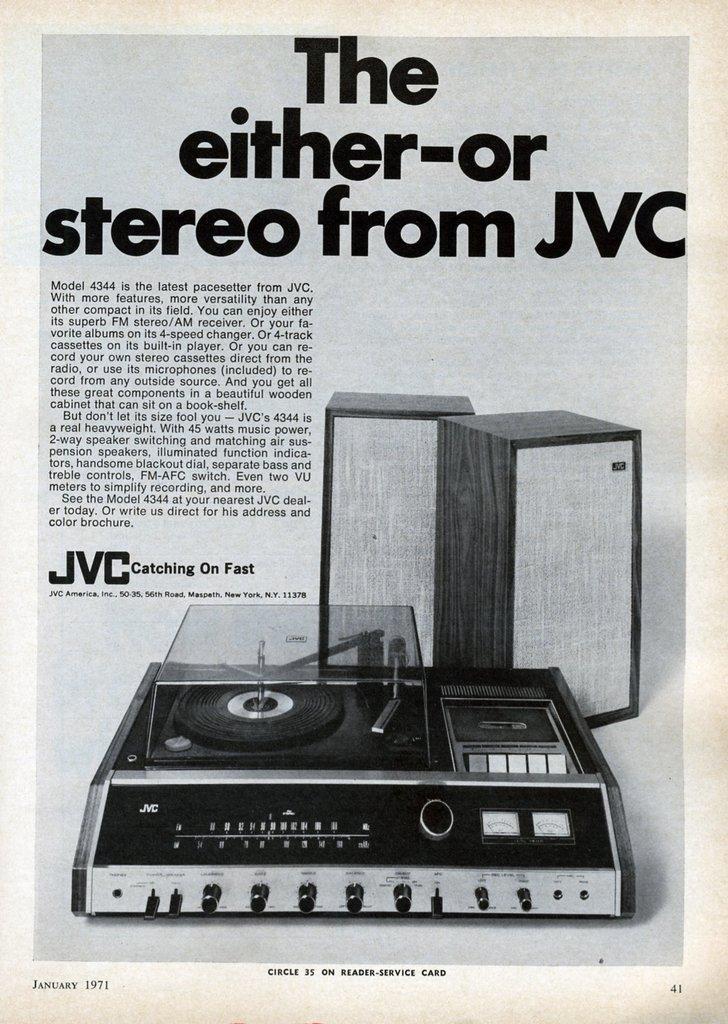Could you give a brief overview of what you see in this image? There is a sound system present at the bottom of this image and there is some text at the top of this image. 